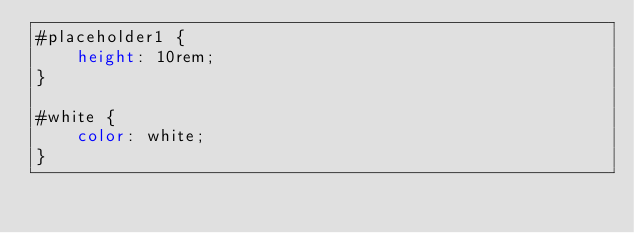Convert code to text. <code><loc_0><loc_0><loc_500><loc_500><_CSS_>#placeholder1 {
    height: 10rem;
}

#white {
    color: white;
}
</code> 